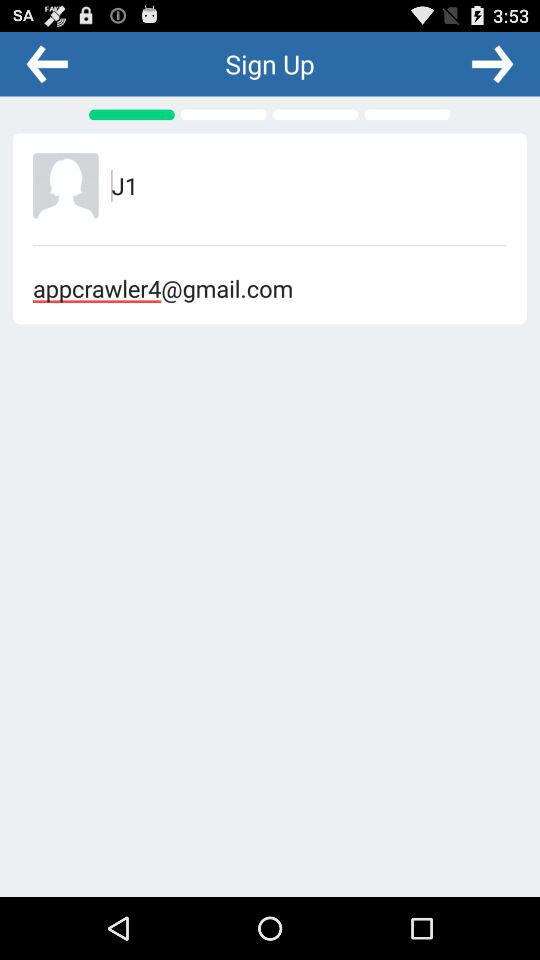What is the email address of the user? The email address is appcrawler4@gmail.com. 